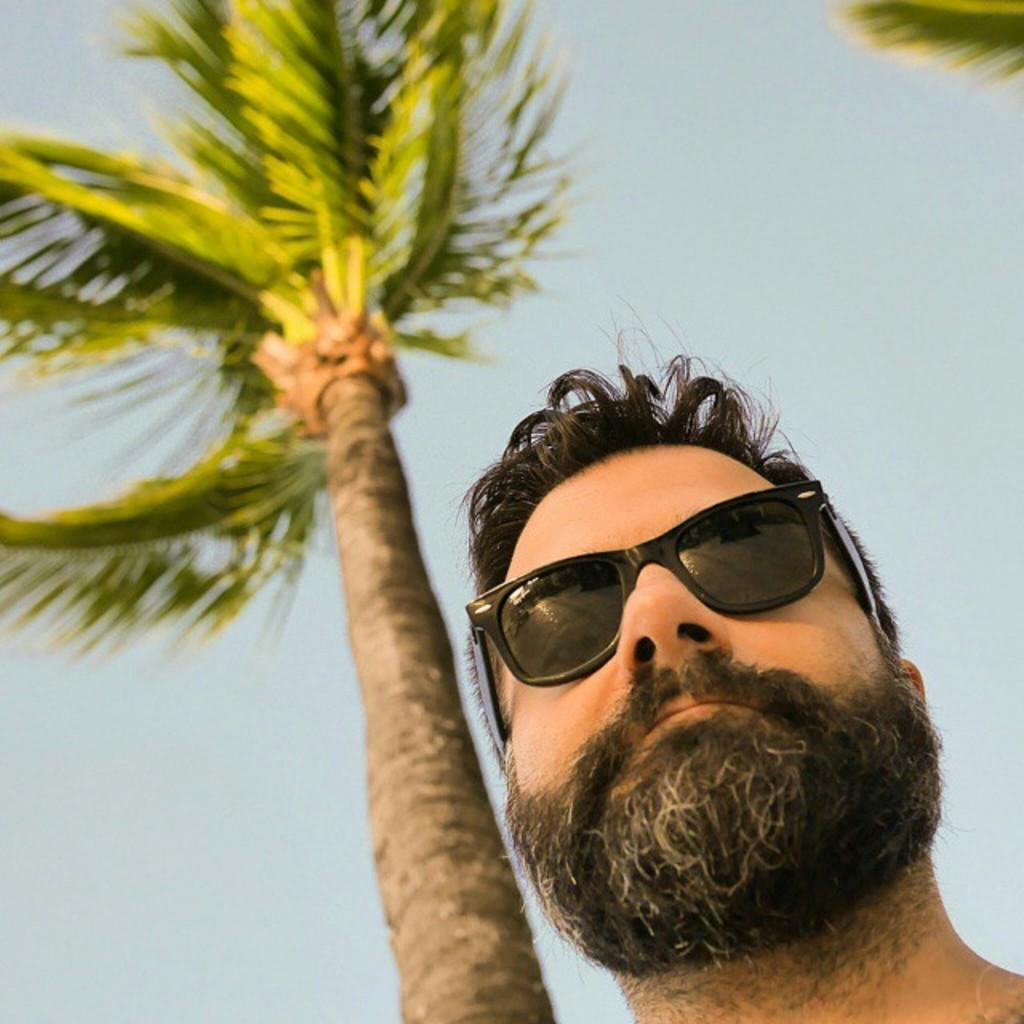Who or what is the main subject in the image? There is a person in the image. What is the person wearing that is noticeable? The person is wearing black color glasses. What can be seen in the background of the image? There is a tree and the sky visible in the background of the image. What type of error can be seen in the image? There is no error present in the image. How many vans are visible in the image? There are no vans present in the image. 